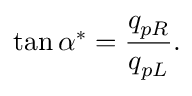Convert formula to latex. <formula><loc_0><loc_0><loc_500><loc_500>\tan \alpha ^ { * } = \frac { q _ { p R } } { q _ { p L } } .</formula> 